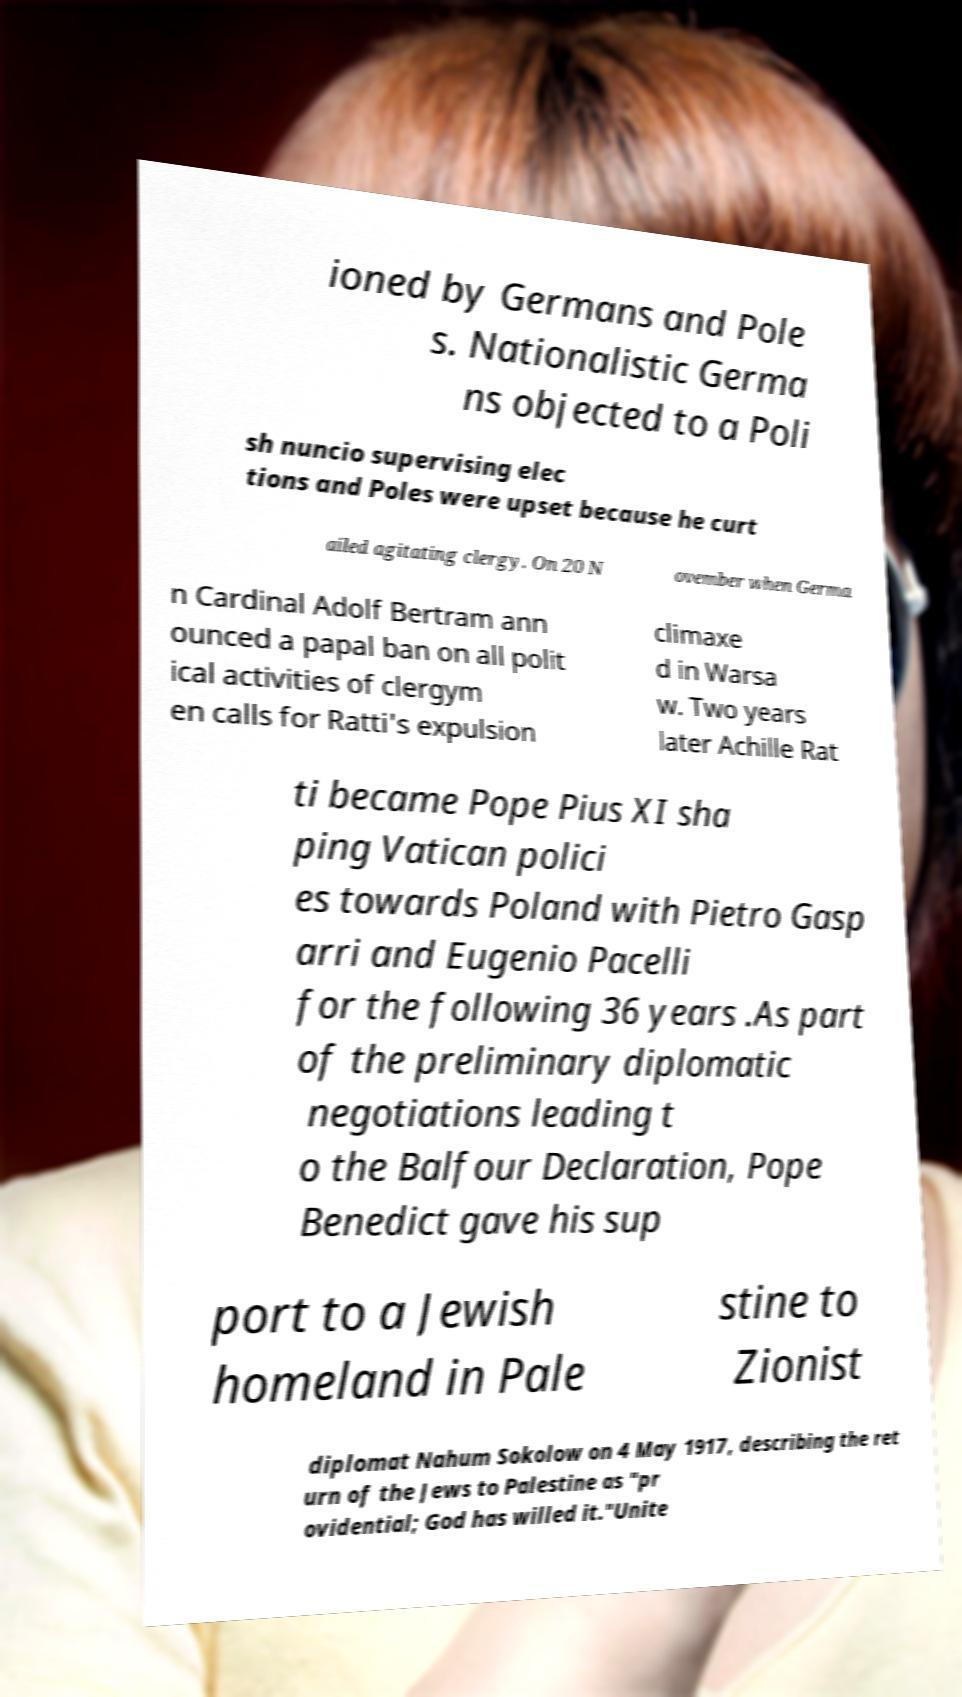Please read and relay the text visible in this image. What does it say? ioned by Germans and Pole s. Nationalistic Germa ns objected to a Poli sh nuncio supervising elec tions and Poles were upset because he curt ailed agitating clergy. On 20 N ovember when Germa n Cardinal Adolf Bertram ann ounced a papal ban on all polit ical activities of clergym en calls for Ratti's expulsion climaxe d in Warsa w. Two years later Achille Rat ti became Pope Pius XI sha ping Vatican polici es towards Poland with Pietro Gasp arri and Eugenio Pacelli for the following 36 years .As part of the preliminary diplomatic negotiations leading t o the Balfour Declaration, Pope Benedict gave his sup port to a Jewish homeland in Pale stine to Zionist diplomat Nahum Sokolow on 4 May 1917, describing the ret urn of the Jews to Palestine as "pr ovidential; God has willed it."Unite 